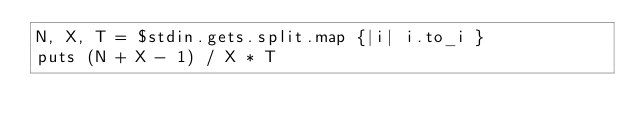<code> <loc_0><loc_0><loc_500><loc_500><_Ruby_>N, X, T = $stdin.gets.split.map {|i| i.to_i }
puts (N + X - 1) / X * T
</code> 